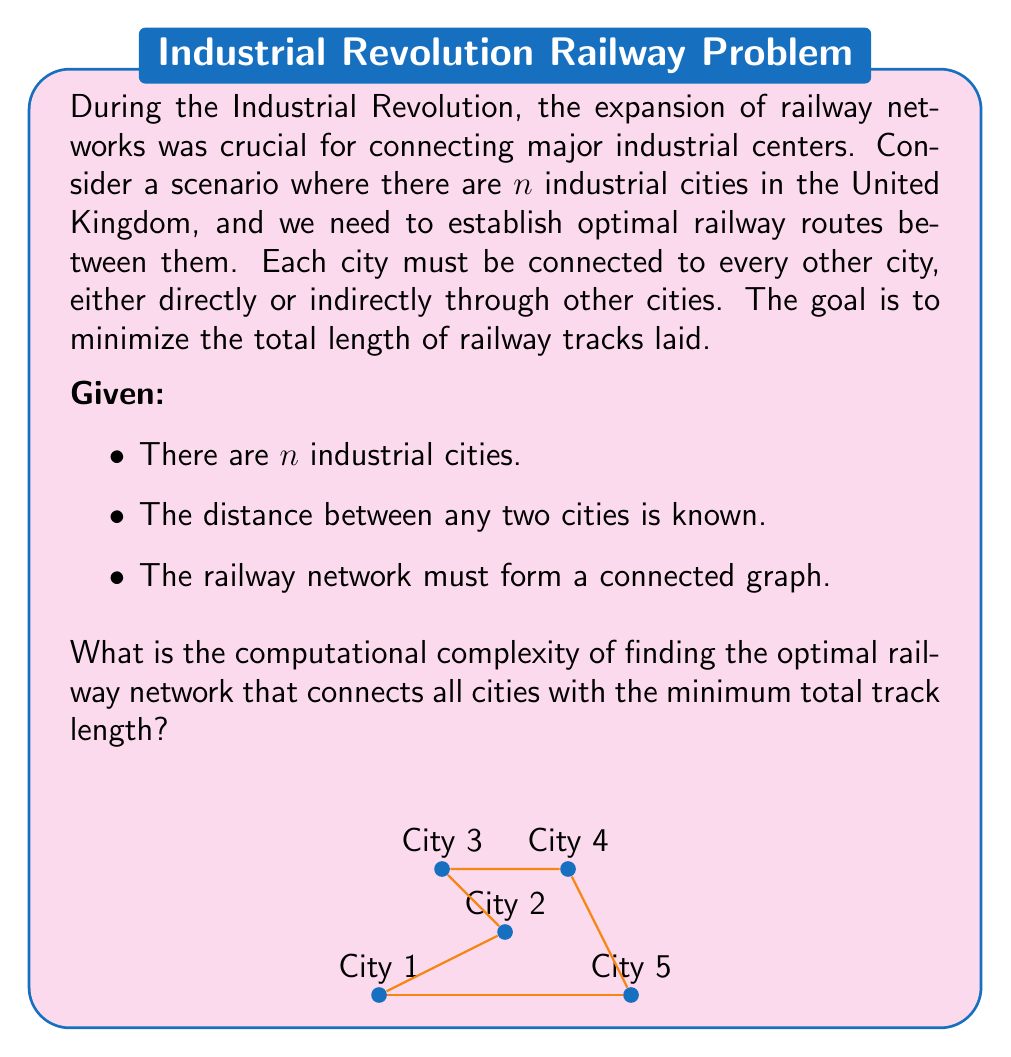Solve this math problem. To solve this problem, we need to understand the following steps:

1) The problem described is equivalent to finding the Minimum Spanning Tree (MST) in a complete graph where:
   - Vertices represent industrial cities
   - Edges represent potential railway connections
   - Edge weights represent distances between cities

2) The MST problem can be solved efficiently using algorithms like Kruskal's or Prim's algorithm.

3) Kruskal's algorithm:
   - Sort all edges in non-decreasing order of weight: $O(E \log E)$
   - Iterate through edges, adding to MST if it doesn't create a cycle: $O(E \alpha(V))$
   Where $E$ is the number of edges, $V$ is the number of vertices, and $\alpha$ is the inverse Ackermann function.

4) In a complete graph with $n$ vertices:
   - Number of edges $E = \frac{n(n-1)}{2} = O(n^2)$

5) Substituting this into the complexity of Kruskal's algorithm:
   - Sorting: $O(n^2 \log n^2) = O(n^2 \log n)$
   - Iterating: $O(n^2 \alpha(n))$

6) The inverse Ackermann function $\alpha(n)$ grows extremely slowly and is effectively constant for all practical values of $n$.

7) Therefore, the dominant term is $O(n^2 \log n)$.

Thus, the computational complexity of finding the optimal railway network is $O(n^2 \log n)$, where $n$ is the number of industrial cities.
Answer: $O(n^2 \log n)$ 